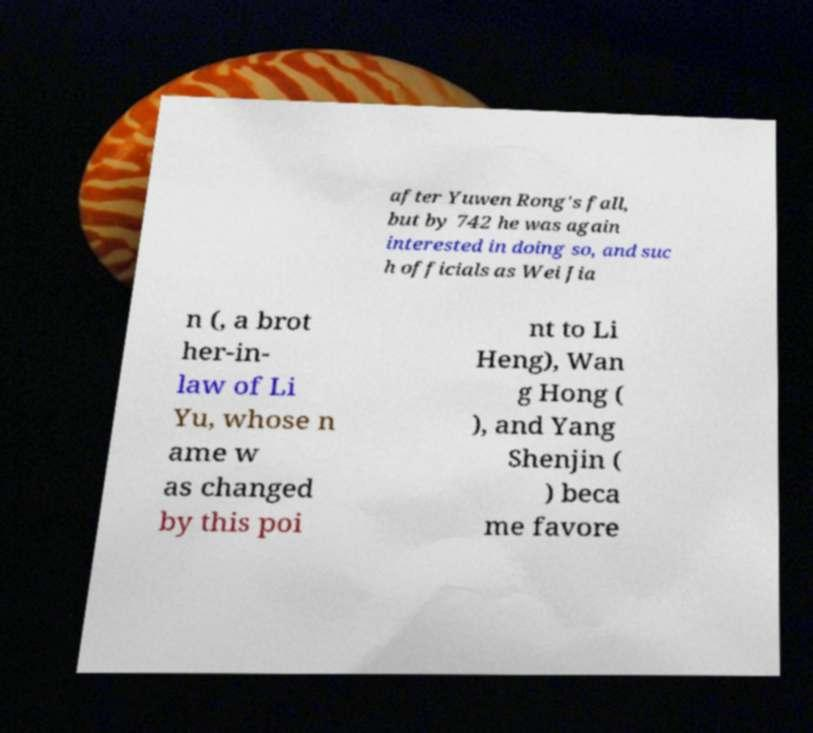Please identify and transcribe the text found in this image. after Yuwen Rong's fall, but by 742 he was again interested in doing so, and suc h officials as Wei Jia n (, a brot her-in- law of Li Yu, whose n ame w as changed by this poi nt to Li Heng), Wan g Hong ( ), and Yang Shenjin ( ) beca me favore 